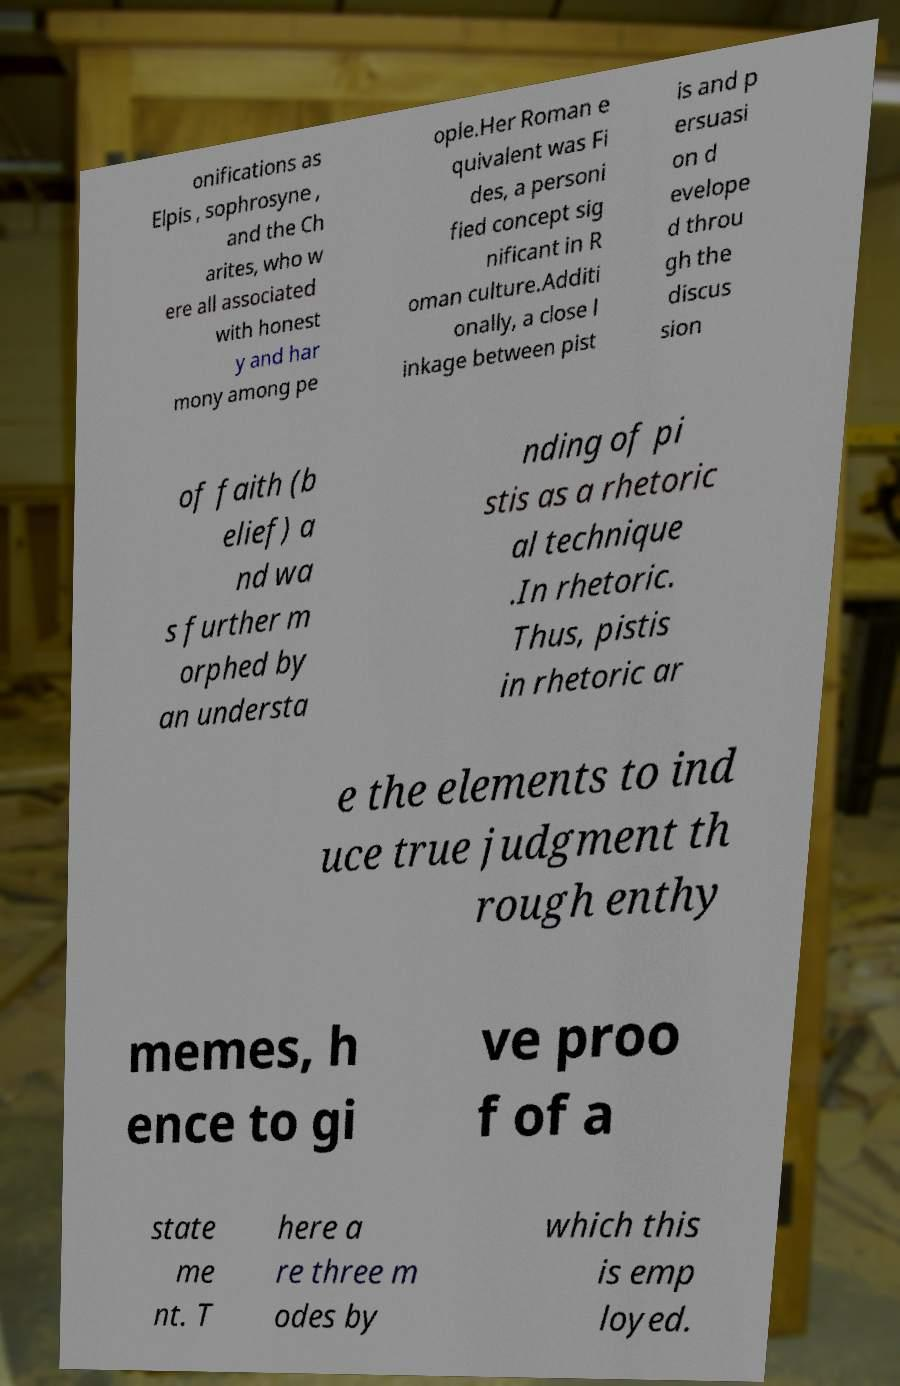Could you assist in decoding the text presented in this image and type it out clearly? onifications as Elpis , sophrosyne , and the Ch arites, who w ere all associated with honest y and har mony among pe ople.Her Roman e quivalent was Fi des, a personi fied concept sig nificant in R oman culture.Additi onally, a close l inkage between pist is and p ersuasi on d evelope d throu gh the discus sion of faith (b elief) a nd wa s further m orphed by an understa nding of pi stis as a rhetoric al technique .In rhetoric. Thus, pistis in rhetoric ar e the elements to ind uce true judgment th rough enthy memes, h ence to gi ve proo f of a state me nt. T here a re three m odes by which this is emp loyed. 